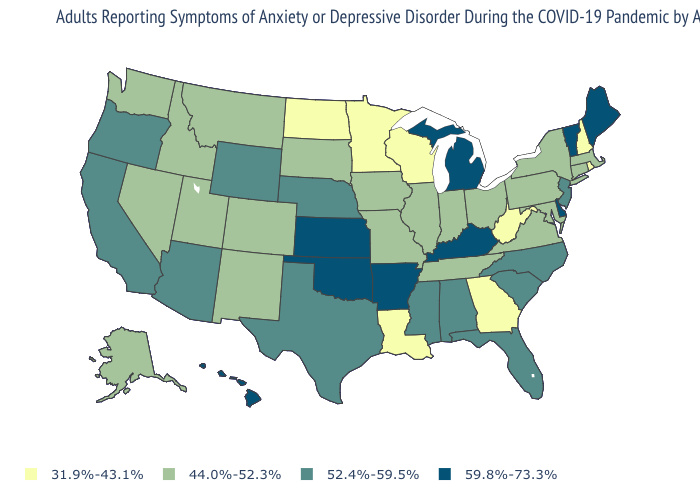What is the value of Alabama?
Give a very brief answer. 52.4%-59.5%. Does the map have missing data?
Quick response, please. No. What is the value of Pennsylvania?
Concise answer only. 44.0%-52.3%. Name the states that have a value in the range 31.9%-43.1%?
Answer briefly. Georgia, Louisiana, Minnesota, New Hampshire, North Dakota, Rhode Island, West Virginia, Wisconsin. Is the legend a continuous bar?
Answer briefly. No. Name the states that have a value in the range 44.0%-52.3%?
Short answer required. Alaska, Colorado, Connecticut, Idaho, Illinois, Indiana, Iowa, Maryland, Massachusetts, Missouri, Montana, Nevada, New Mexico, New York, Ohio, Pennsylvania, South Dakota, Tennessee, Utah, Virginia, Washington. Does North Carolina have a higher value than Kansas?
Give a very brief answer. No. What is the value of California?
Quick response, please. 52.4%-59.5%. Among the states that border Georgia , does Alabama have the lowest value?
Concise answer only. No. What is the value of Iowa?
Concise answer only. 44.0%-52.3%. Does Oklahoma have the highest value in the USA?
Be succinct. Yes. Among the states that border New York , which have the lowest value?
Short answer required. Connecticut, Massachusetts, Pennsylvania. Name the states that have a value in the range 59.8%-73.3%?
Be succinct. Arkansas, Delaware, Hawaii, Kansas, Kentucky, Maine, Michigan, Oklahoma, Vermont. Is the legend a continuous bar?
Answer briefly. No. 